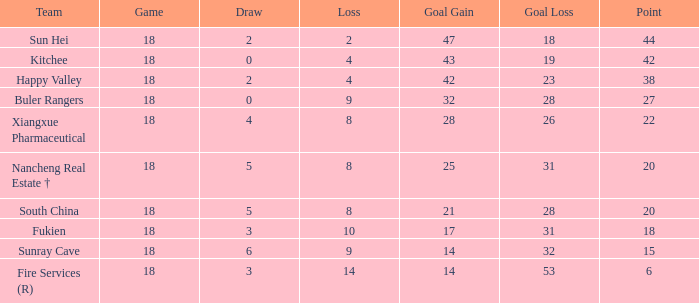What team with a Game smaller than 18 has the lowest Goal Gain? None. 